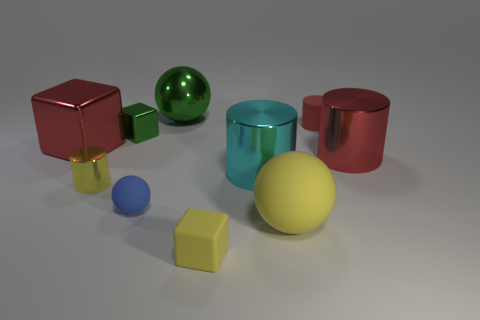The green cube that is the same material as the green ball is what size?
Make the answer very short. Small. There is a small object that is the same color as the metal ball; what shape is it?
Offer a very short reply. Cube. How big is the cube that is both in front of the small metal block and on the left side of the blue sphere?
Your response must be concise. Large. What is the color of the metallic cube that is the same size as the red matte object?
Your response must be concise. Green. Is the tiny yellow cylinder made of the same material as the small red thing?
Give a very brief answer. No. What number of objects are red shiny things on the right side of the big rubber sphere or large green rubber balls?
Offer a very short reply. 1. What number of other objects are there of the same size as the green shiny sphere?
Ensure brevity in your answer.  4. Are there the same number of large shiny cylinders that are to the right of the big red block and tiny metal cubes right of the blue rubber sphere?
Offer a very short reply. No. There is another matte object that is the same shape as the blue rubber object; what color is it?
Keep it short and to the point. Yellow. Is there anything else that has the same shape as the cyan object?
Make the answer very short. Yes. 